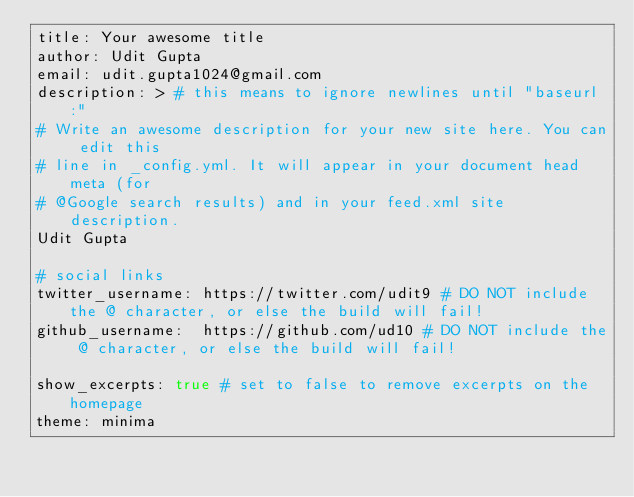Convert code to text. <code><loc_0><loc_0><loc_500><loc_500><_YAML_>title: Your awesome title
author: Udit Gupta
email: udit.gupta1024@gmail.com
description: > # this means to ignore newlines until "baseurl:"
# Write an awesome description for your new site here. You can edit this
# line in _config.yml. It will appear in your document head meta (for
# @Google search results) and in your feed.xml site description.
Udit Gupta

# social links
twitter_username: https://twitter.com/udit9 # DO NOT include the @ character, or else the build will fail!
github_username:  https://github.com/ud10 # DO NOT include the @ character, or else the build will fail!

show_excerpts: true # set to false to remove excerpts on the homepage
theme: minima
</code> 